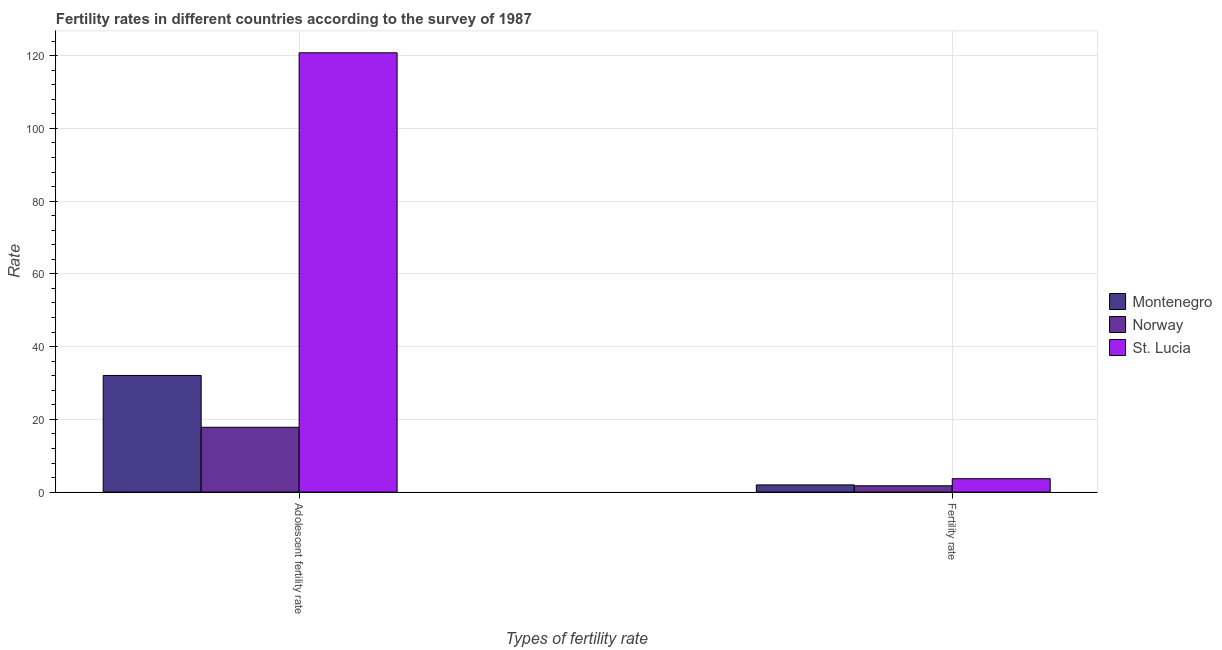How many groups of bars are there?
Provide a short and direct response. 2. What is the label of the 2nd group of bars from the left?
Offer a terse response. Fertility rate. What is the fertility rate in St. Lucia?
Your response must be concise. 3.68. Across all countries, what is the maximum adolescent fertility rate?
Your response must be concise. 120.79. Across all countries, what is the minimum adolescent fertility rate?
Your response must be concise. 17.83. In which country was the adolescent fertility rate maximum?
Keep it short and to the point. St. Lucia. What is the total fertility rate in the graph?
Provide a succinct answer. 7.4. What is the difference between the adolescent fertility rate in St. Lucia and that in Norway?
Your response must be concise. 102.97. What is the difference between the adolescent fertility rate in Montenegro and the fertility rate in St. Lucia?
Keep it short and to the point. 28.39. What is the average adolescent fertility rate per country?
Your answer should be very brief. 56.9. What is the difference between the adolescent fertility rate and fertility rate in St. Lucia?
Offer a very short reply. 117.11. What is the ratio of the fertility rate in St. Lucia to that in Norway?
Make the answer very short. 2.12. In how many countries, is the adolescent fertility rate greater than the average adolescent fertility rate taken over all countries?
Keep it short and to the point. 1. What does the 1st bar from the left in Adolescent fertility rate represents?
Offer a terse response. Montenegro. What does the 1st bar from the right in Adolescent fertility rate represents?
Provide a short and direct response. St. Lucia. How many countries are there in the graph?
Give a very brief answer. 3. What is the difference between two consecutive major ticks on the Y-axis?
Give a very brief answer. 20. Does the graph contain any zero values?
Offer a terse response. No. Does the graph contain grids?
Your answer should be very brief. Yes. What is the title of the graph?
Your response must be concise. Fertility rates in different countries according to the survey of 1987. What is the label or title of the X-axis?
Your response must be concise. Types of fertility rate. What is the label or title of the Y-axis?
Your response must be concise. Rate. What is the Rate of Montenegro in Adolescent fertility rate?
Provide a succinct answer. 32.07. What is the Rate of Norway in Adolescent fertility rate?
Your answer should be very brief. 17.83. What is the Rate of St. Lucia in Adolescent fertility rate?
Provide a short and direct response. 120.79. What is the Rate in Montenegro in Fertility rate?
Offer a terse response. 1.98. What is the Rate in Norway in Fertility rate?
Your response must be concise. 1.74. What is the Rate in St. Lucia in Fertility rate?
Provide a succinct answer. 3.68. Across all Types of fertility rate, what is the maximum Rate of Montenegro?
Ensure brevity in your answer.  32.07. Across all Types of fertility rate, what is the maximum Rate of Norway?
Your answer should be compact. 17.83. Across all Types of fertility rate, what is the maximum Rate in St. Lucia?
Your answer should be very brief. 120.79. Across all Types of fertility rate, what is the minimum Rate in Montenegro?
Your response must be concise. 1.98. Across all Types of fertility rate, what is the minimum Rate in Norway?
Provide a succinct answer. 1.74. Across all Types of fertility rate, what is the minimum Rate in St. Lucia?
Offer a very short reply. 3.68. What is the total Rate of Montenegro in the graph?
Your answer should be very brief. 34.05. What is the total Rate of Norway in the graph?
Your answer should be very brief. 19.57. What is the total Rate of St. Lucia in the graph?
Make the answer very short. 124.48. What is the difference between the Rate of Montenegro in Adolescent fertility rate and that in Fertility rate?
Keep it short and to the point. 30.09. What is the difference between the Rate in Norway in Adolescent fertility rate and that in Fertility rate?
Offer a very short reply. 16.09. What is the difference between the Rate of St. Lucia in Adolescent fertility rate and that in Fertility rate?
Offer a very short reply. 117.11. What is the difference between the Rate in Montenegro in Adolescent fertility rate and the Rate in Norway in Fertility rate?
Ensure brevity in your answer.  30.33. What is the difference between the Rate of Montenegro in Adolescent fertility rate and the Rate of St. Lucia in Fertility rate?
Offer a terse response. 28.39. What is the difference between the Rate of Norway in Adolescent fertility rate and the Rate of St. Lucia in Fertility rate?
Your response must be concise. 14.14. What is the average Rate in Montenegro per Types of fertility rate?
Keep it short and to the point. 17.02. What is the average Rate in Norway per Types of fertility rate?
Offer a terse response. 9.78. What is the average Rate in St. Lucia per Types of fertility rate?
Offer a terse response. 62.24. What is the difference between the Rate of Montenegro and Rate of Norway in Adolescent fertility rate?
Give a very brief answer. 14.24. What is the difference between the Rate in Montenegro and Rate in St. Lucia in Adolescent fertility rate?
Provide a short and direct response. -88.72. What is the difference between the Rate of Norway and Rate of St. Lucia in Adolescent fertility rate?
Offer a very short reply. -102.97. What is the difference between the Rate in Montenegro and Rate in Norway in Fertility rate?
Keep it short and to the point. 0.24. What is the difference between the Rate in Montenegro and Rate in St. Lucia in Fertility rate?
Your answer should be very brief. -1.7. What is the difference between the Rate in Norway and Rate in St. Lucia in Fertility rate?
Make the answer very short. -1.94. What is the ratio of the Rate in Montenegro in Adolescent fertility rate to that in Fertility rate?
Your answer should be very brief. 16.2. What is the ratio of the Rate in Norway in Adolescent fertility rate to that in Fertility rate?
Your answer should be compact. 10.25. What is the ratio of the Rate in St. Lucia in Adolescent fertility rate to that in Fertility rate?
Give a very brief answer. 32.8. What is the difference between the highest and the second highest Rate of Montenegro?
Give a very brief answer. 30.09. What is the difference between the highest and the second highest Rate of Norway?
Your answer should be very brief. 16.09. What is the difference between the highest and the second highest Rate in St. Lucia?
Offer a very short reply. 117.11. What is the difference between the highest and the lowest Rate of Montenegro?
Ensure brevity in your answer.  30.09. What is the difference between the highest and the lowest Rate of Norway?
Keep it short and to the point. 16.09. What is the difference between the highest and the lowest Rate of St. Lucia?
Your answer should be compact. 117.11. 